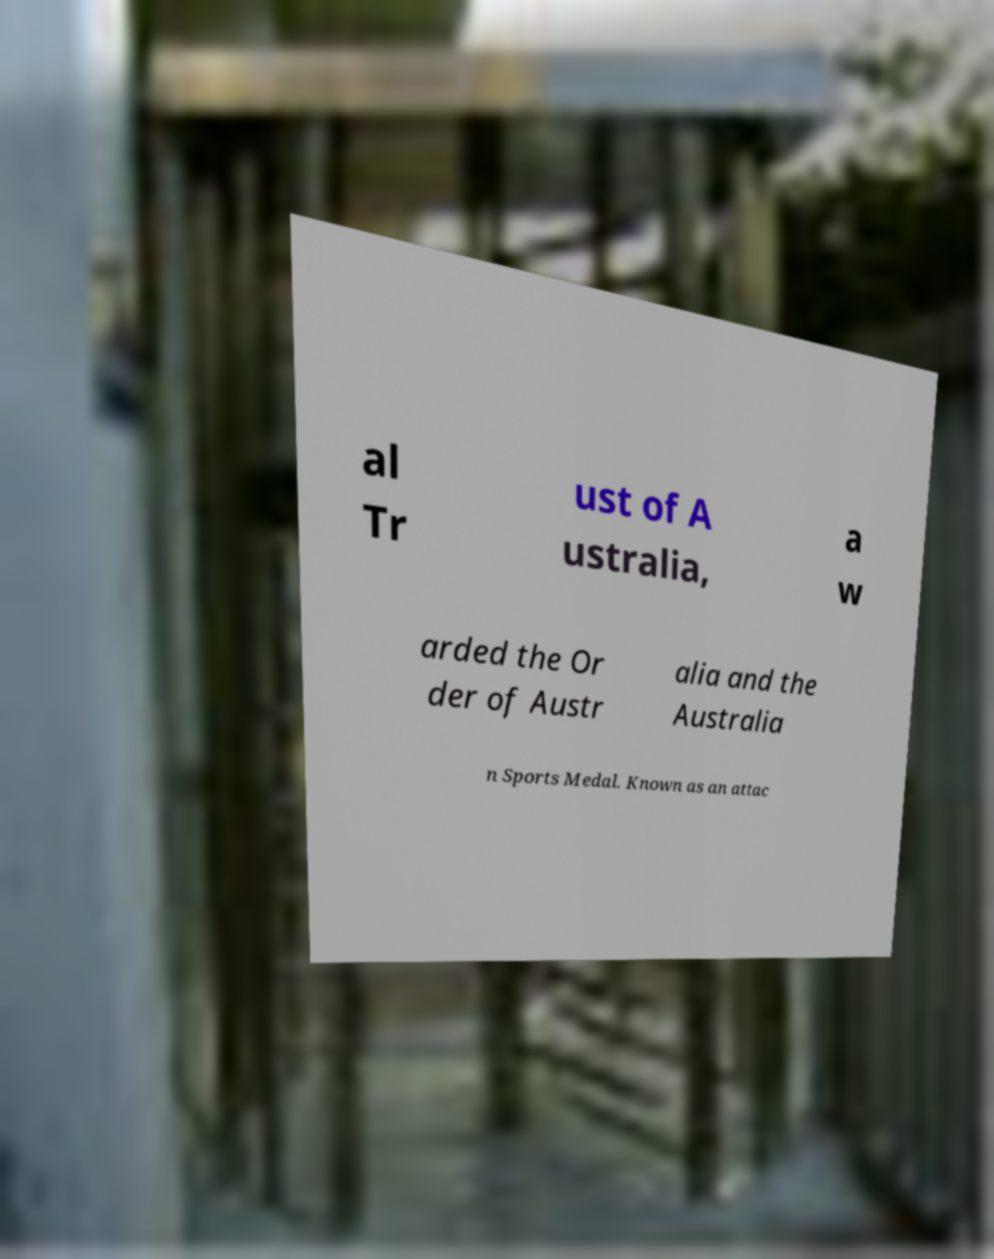Can you accurately transcribe the text from the provided image for me? al Tr ust of A ustralia, a w arded the Or der of Austr alia and the Australia n Sports Medal. Known as an attac 